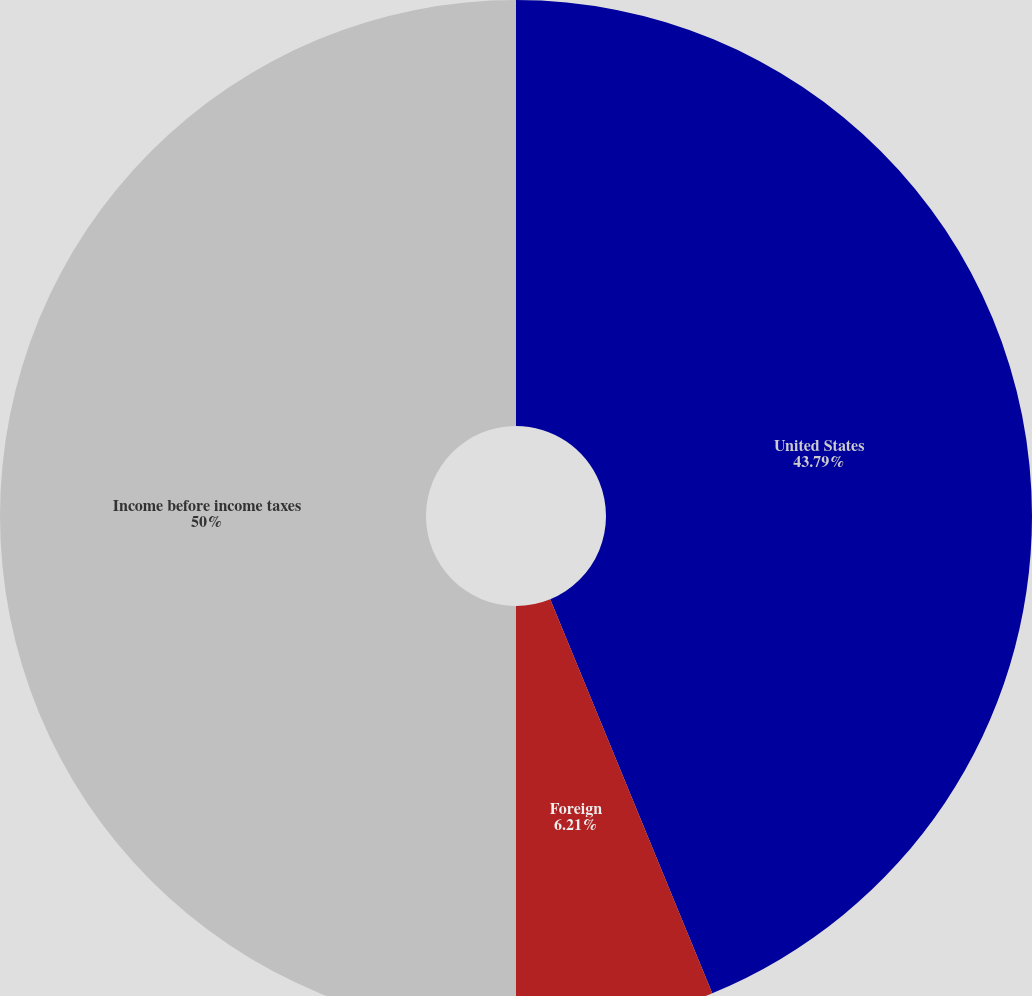Convert chart to OTSL. <chart><loc_0><loc_0><loc_500><loc_500><pie_chart><fcel>United States<fcel>Foreign<fcel>Income before income taxes<nl><fcel>43.79%<fcel>6.21%<fcel>50.0%<nl></chart> 